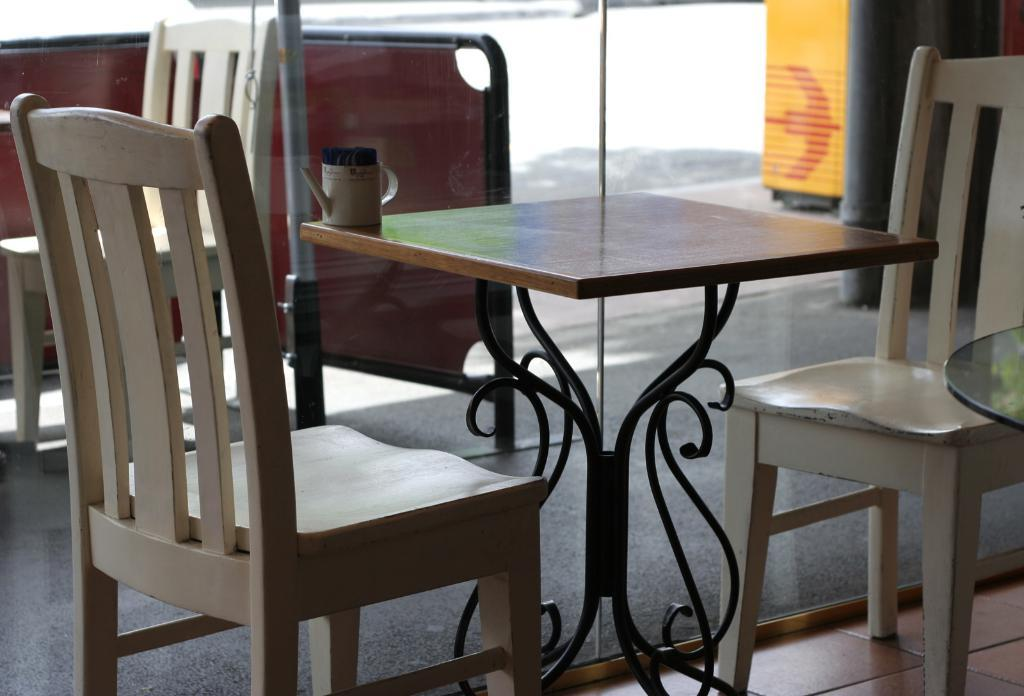What type of furniture is present in the image? There are chairs and tables in the image. Can you describe the object on one of the tables? There is a jar on one of the tables. What type of door is visible in the image? There is a glass door in the image. How many cows can be seen grazing in the image? There are no cows present in the image. What type of journey is depicted in the image? There is no journey depicted in the image; it features chairs, tables, a jar, and a glass door. 